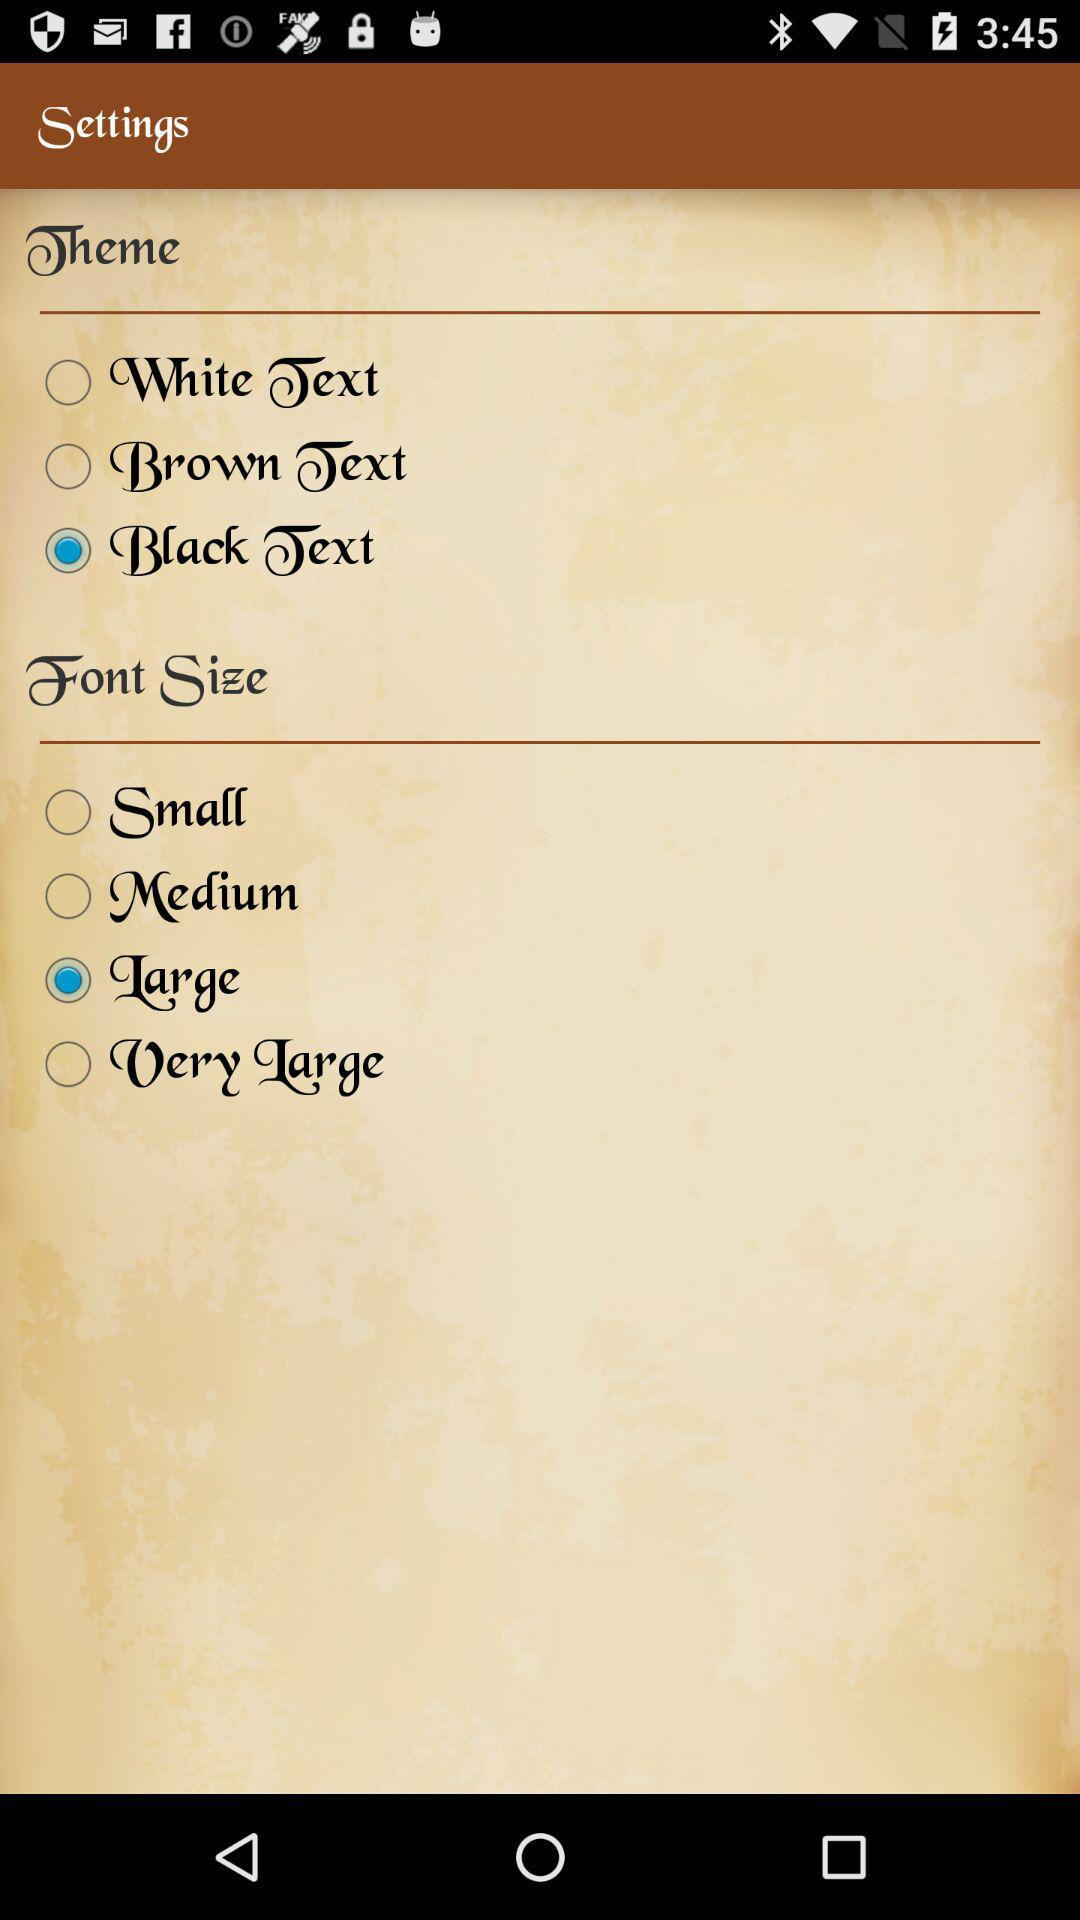How many font size options are there?
Answer the question using a single word or phrase. 4 